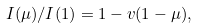Convert formula to latex. <formula><loc_0><loc_0><loc_500><loc_500>I ( \mu ) / I ( 1 ) = 1 - v ( 1 - \mu ) ,</formula> 